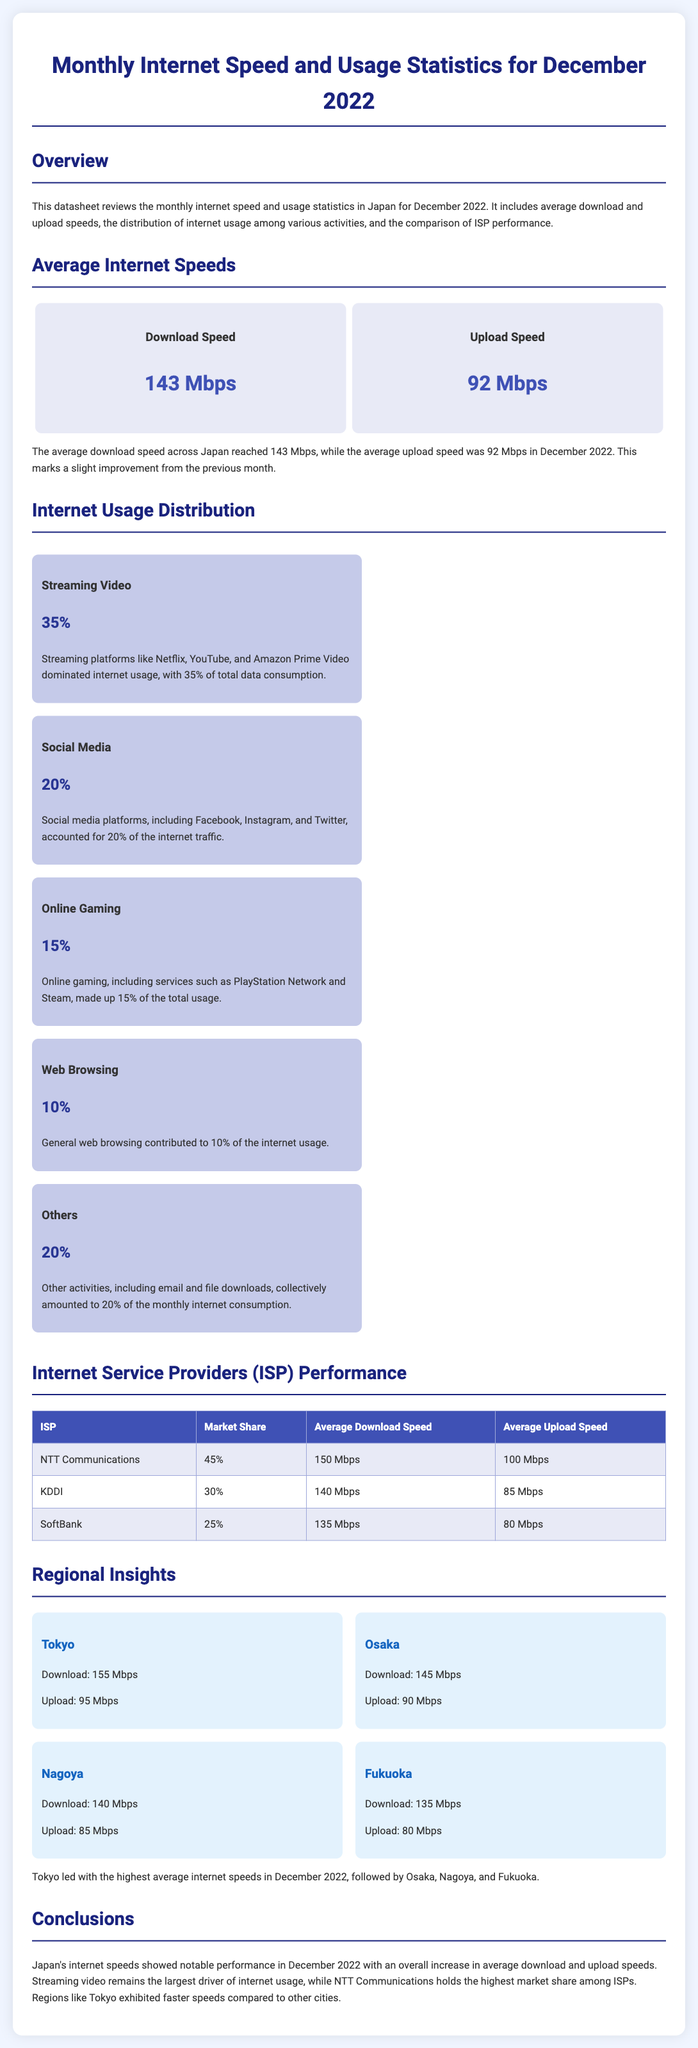What was the average download speed in December 2022? The average download speed across Japan was 143 Mbps in December 2022.
Answer: 143 Mbps What percentage of internet usage was attributed to streaming video? Streaming video accounted for 35% of total data consumption in December 2022.
Answer: 35% Which ISP had the highest market share? NTT Communications had the highest market share, which was 45%.
Answer: 45% What was the average upload speed for KDDI? KDDI's average upload speed was 85 Mbps in December 2022.
Answer: 85 Mbps Which region had the highest average download speed? Tokyo had the highest average download speed at 155 Mbps.
Answer: Tokyo How much of the internet usage was due to online gaming? Online gaming made up 15% of the total internet usage.
Answer: 15% What was the average download speed for Fukuoka? Fukuoka's average download speed was 135 Mbps.
Answer: 135 Mbps What was the average upload speed across Japan in December 2022? The average upload speed in Japan was 92 Mbps.
Answer: 92 Mbps What is the total market share represented by SoftBank? SoftBank's market share was 25%.
Answer: 25% 